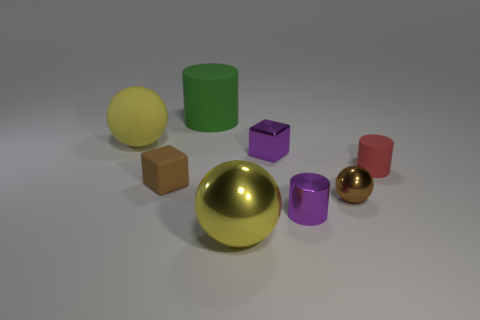How many shiny objects are small cyan cubes or large green things?
Keep it short and to the point. 0. Is the number of large green matte objects that are right of the purple cylinder less than the number of tiny spheres?
Your response must be concise. Yes. There is a big object that is in front of the small purple shiny object behind the brown object that is in front of the brown block; what shape is it?
Ensure brevity in your answer.  Sphere. Does the shiny cylinder have the same color as the shiny cube?
Your response must be concise. Yes. Are there more brown rubber cubes than rubber things?
Offer a very short reply. No. What number of other objects are there of the same material as the large green cylinder?
Ensure brevity in your answer.  3. How many objects are small cylinders or matte objects on the right side of the large yellow rubber ball?
Keep it short and to the point. 4. Are there fewer large red objects than red rubber things?
Offer a very short reply. Yes. The big metal object that is to the right of the big ball that is behind the large yellow sphere in front of the large matte sphere is what color?
Your answer should be very brief. Yellow. Does the large green thing have the same material as the tiny red object?
Make the answer very short. Yes. 